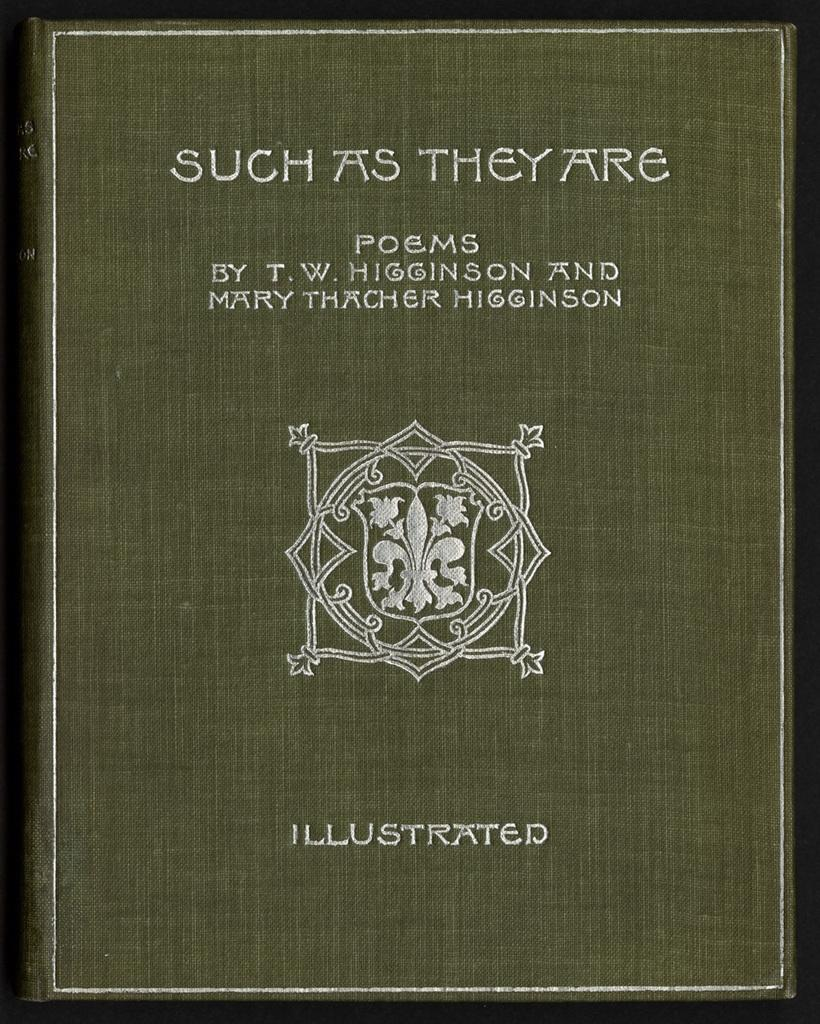<image>
Relay a brief, clear account of the picture shown. A book of poems by T.W. Higginson and Mary Thatcher Higginson titled Such As They Are 